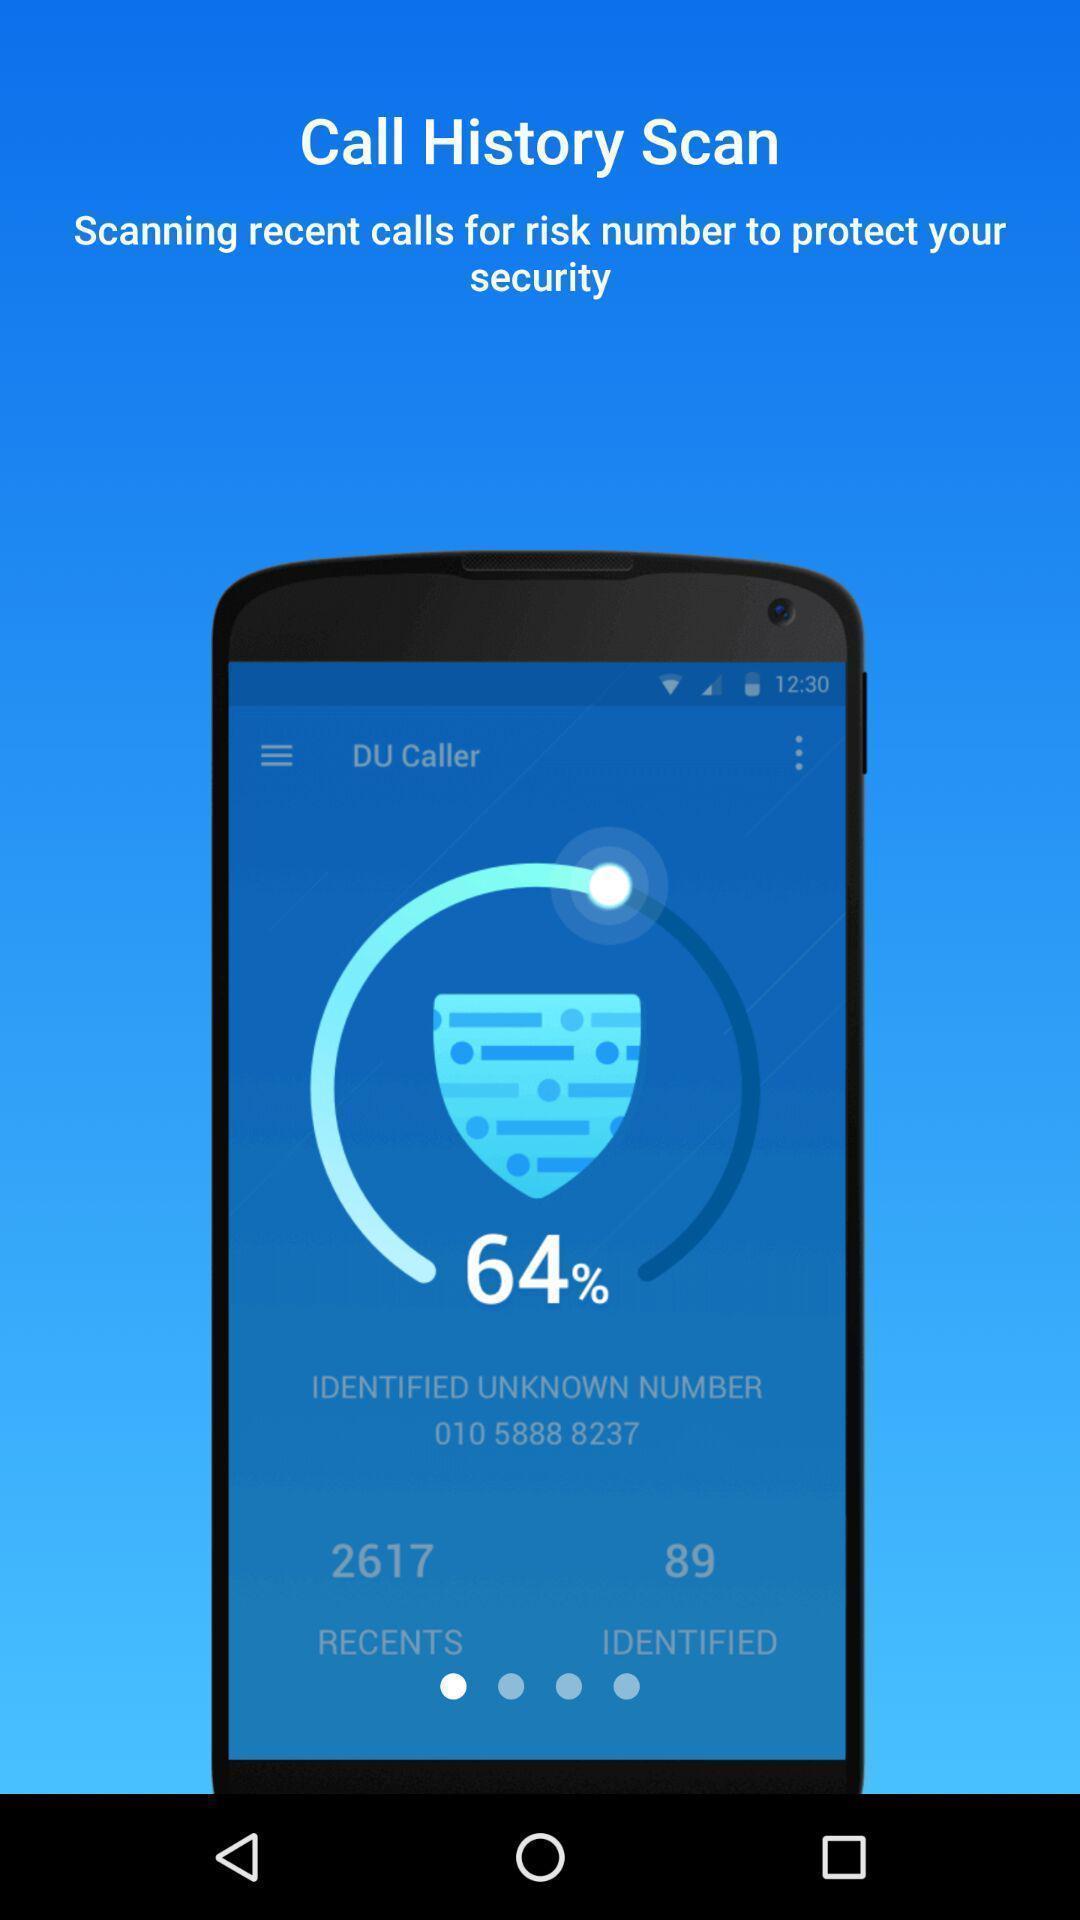What can you discern from this picture? Page showing scanning rate for security purpose. 